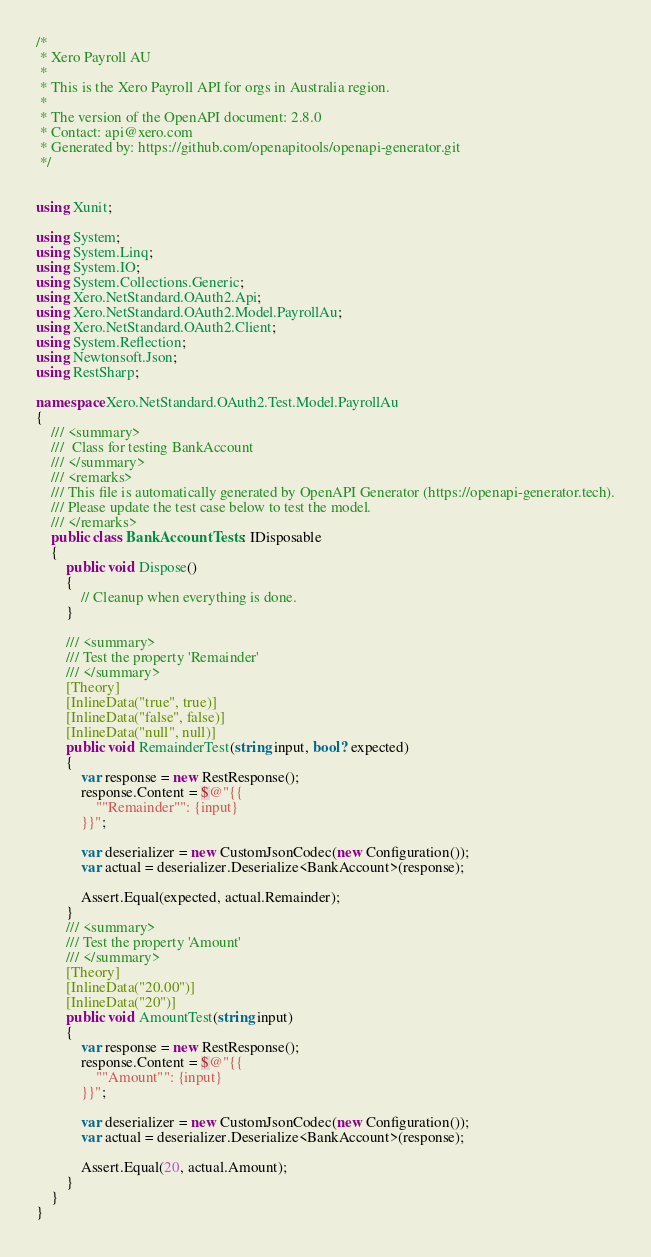<code> <loc_0><loc_0><loc_500><loc_500><_C#_>/* 
 * Xero Payroll AU
 *
 * This is the Xero Payroll API for orgs in Australia region.
 *
 * The version of the OpenAPI document: 2.8.0
 * Contact: api@xero.com
 * Generated by: https://github.com/openapitools/openapi-generator.git
 */


using Xunit;

using System;
using System.Linq;
using System.IO;
using System.Collections.Generic;
using Xero.NetStandard.OAuth2.Api;
using Xero.NetStandard.OAuth2.Model.PayrollAu;
using Xero.NetStandard.OAuth2.Client;
using System.Reflection;
using Newtonsoft.Json;
using RestSharp;

namespace Xero.NetStandard.OAuth2.Test.Model.PayrollAu
{
    /// <summary>
    ///  Class for testing BankAccount
    /// </summary>
    /// <remarks>
    /// This file is automatically generated by OpenAPI Generator (https://openapi-generator.tech).
    /// Please update the test case below to test the model.
    /// </remarks>
    public class BankAccountTests : IDisposable
    {
        public void Dispose()
        {
            // Cleanup when everything is done.
        }

        /// <summary>
        /// Test the property 'Remainder'
        /// </summary>
        [Theory]
        [InlineData("true", true)]
        [InlineData("false", false)]
        [InlineData("null", null)]
        public void RemainderTest(string input, bool? expected)
        {
            var response = new RestResponse();
            response.Content = $@"{{
                ""Remainder"": {input}
            }}";

            var deserializer = new CustomJsonCodec(new Configuration());
            var actual = deserializer.Deserialize<BankAccount>(response);

            Assert.Equal(expected, actual.Remainder);
        }
        /// <summary>
        /// Test the property 'Amount'
        /// </summary>
        [Theory]
        [InlineData("20.00")]
        [InlineData("20")]
        public void AmountTest(string input)
        {
            var response = new RestResponse();
            response.Content = $@"{{
                ""Amount"": {input}
            }}";

            var deserializer = new CustomJsonCodec(new Configuration());
            var actual = deserializer.Deserialize<BankAccount>(response);

            Assert.Equal(20, actual.Amount);
        }
    }
}
</code> 